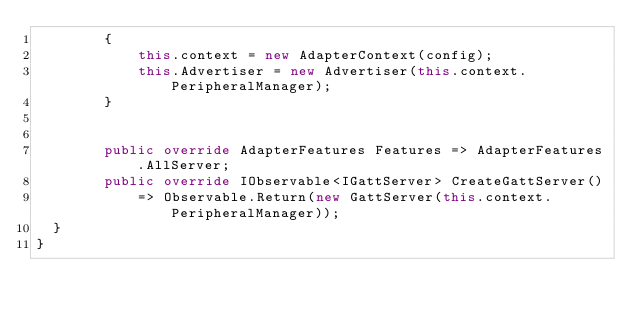Convert code to text. <code><loc_0><loc_0><loc_500><loc_500><_C#_>        {
            this.context = new AdapterContext(config);
            this.Advertiser = new Advertiser(this.context.PeripheralManager);
        }


        public override AdapterFeatures Features => AdapterFeatures.AllServer;
        public override IObservable<IGattServer> CreateGattServer()
            => Observable.Return(new GattServer(this.context.PeripheralManager));
	}
}</code> 